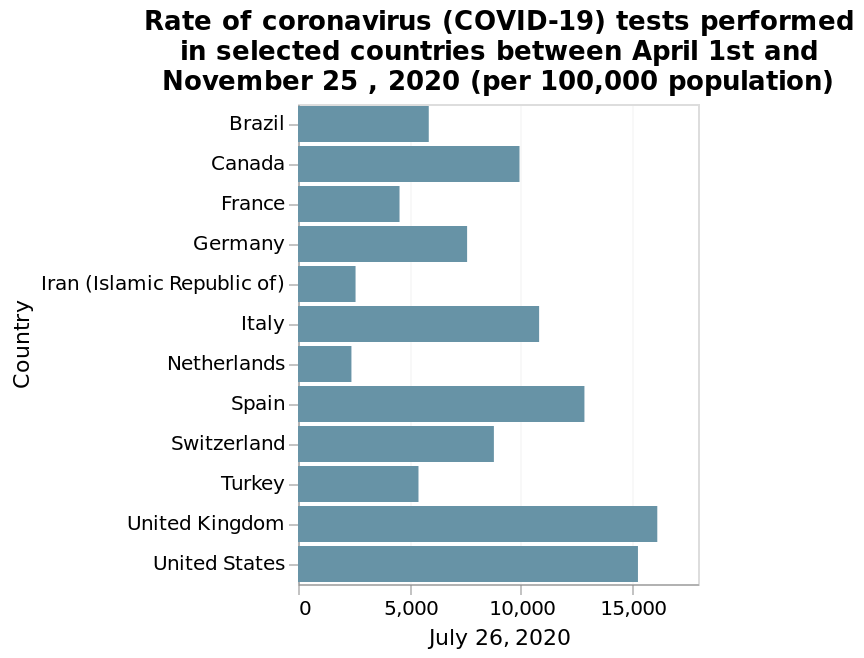<image>
Which countries performed the least COVID tests in this timeframe?  Iran, The Netherlands, and France performed the least COVID tests in this timeframe. Which countries performed the most COVID tests in this timeframe?  The United Kingdom and the United States performed the most COVID tests in this timeframe. What is the variable represented on the x-axis of the bar plot? The x-axis of the bar plot represents the date July 26, 2020. How many COVID tests did the United Kingdom and the United States perform per 100,000 population?  Both countries performed over 15,000 COVID tests per 100,000 population. 